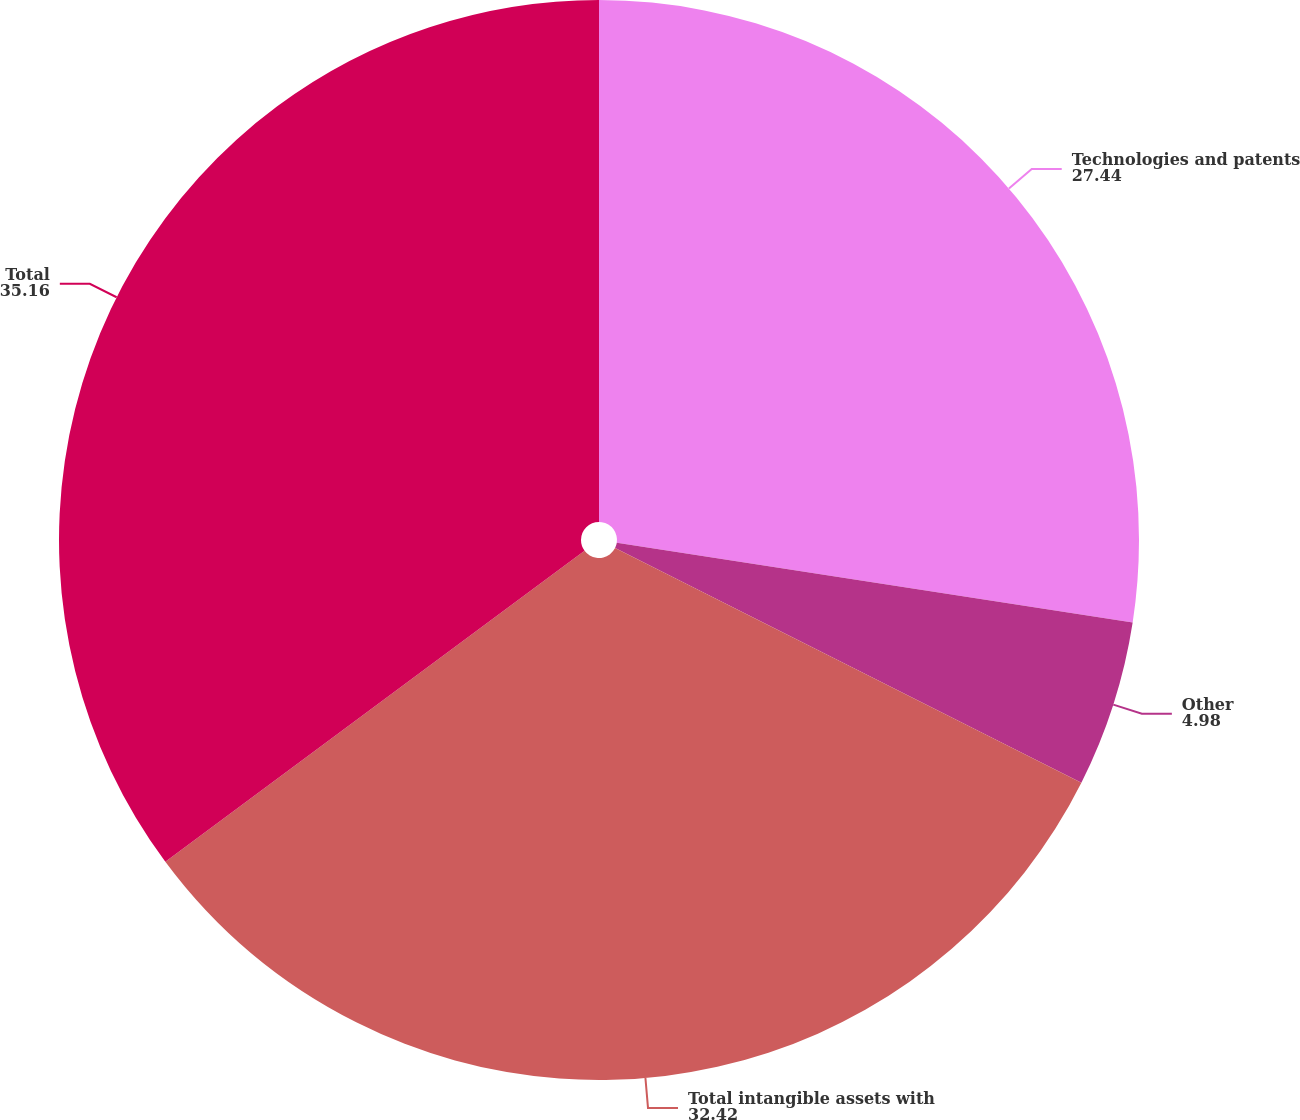Convert chart to OTSL. <chart><loc_0><loc_0><loc_500><loc_500><pie_chart><fcel>Technologies and patents<fcel>Other<fcel>Total intangible assets with<fcel>Total<nl><fcel>27.44%<fcel>4.98%<fcel>32.42%<fcel>35.16%<nl></chart> 